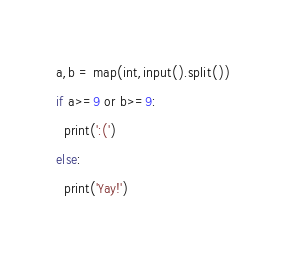<code> <loc_0><loc_0><loc_500><loc_500><_Python_>a,b = map(int,input().split())
if a>=9 or b>=9:
  print(':(')
else:
  print('Yay!')</code> 